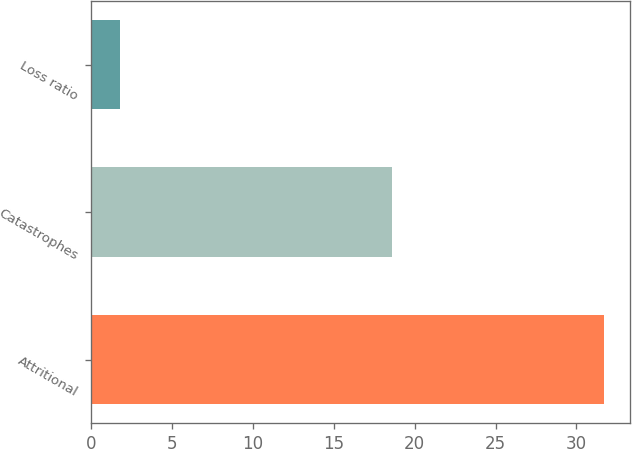<chart> <loc_0><loc_0><loc_500><loc_500><bar_chart><fcel>Attritional<fcel>Catastrophes<fcel>Loss ratio<nl><fcel>31.7<fcel>18.6<fcel>1.8<nl></chart> 